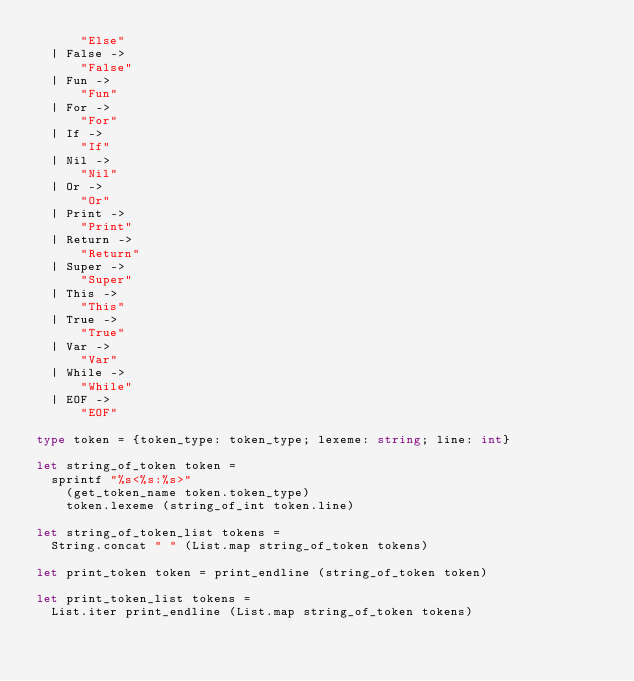<code> <loc_0><loc_0><loc_500><loc_500><_OCaml_>      "Else"
  | False ->
      "False"
  | Fun ->
      "Fun"
  | For ->
      "For"
  | If ->
      "If"
  | Nil ->
      "Nil"
  | Or ->
      "Or"
  | Print ->
      "Print"
  | Return ->
      "Return"
  | Super ->
      "Super"
  | This ->
      "This"
  | True ->
      "True"
  | Var ->
      "Var"
  | While ->
      "While"
  | EOF ->
      "EOF"

type token = {token_type: token_type; lexeme: string; line: int}

let string_of_token token =
  sprintf "%s<%s:%s>"
    (get_token_name token.token_type)
    token.lexeme (string_of_int token.line)

let string_of_token_list tokens =
  String.concat " " (List.map string_of_token tokens)

let print_token token = print_endline (string_of_token token)

let print_token_list tokens =
  List.iter print_endline (List.map string_of_token tokens)
</code> 